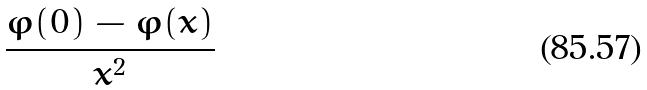Convert formula to latex. <formula><loc_0><loc_0><loc_500><loc_500>\frac { \varphi ( 0 ) - \varphi ( x ) } { x ^ { 2 } }</formula> 